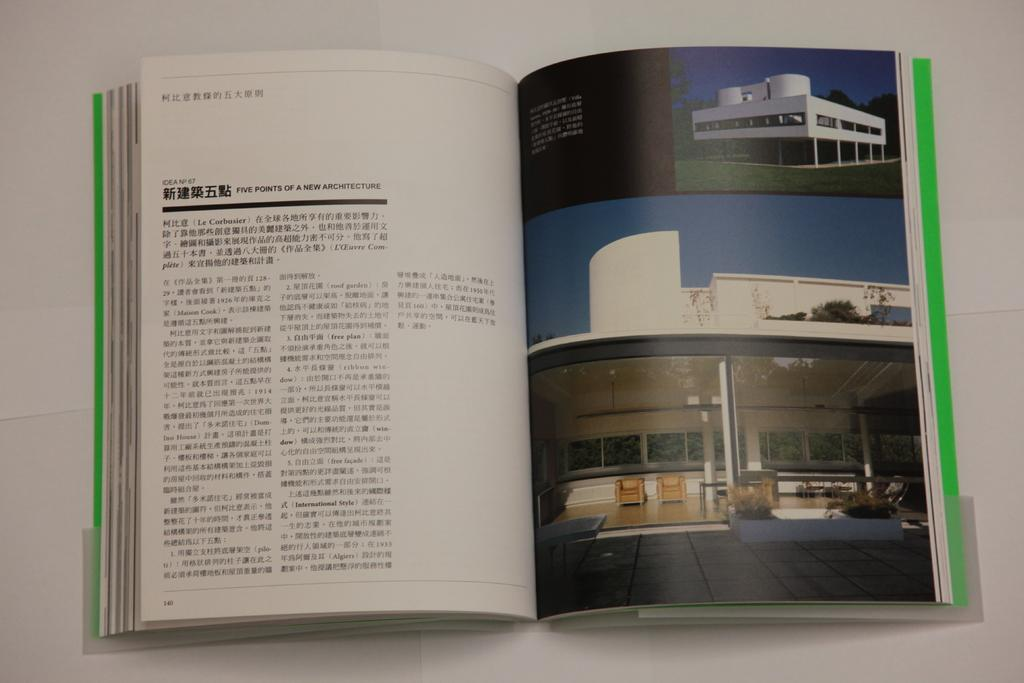<image>
Write a terse but informative summary of the picture. A book with some Japanese text and pictures of buildings on the adjacent page. 